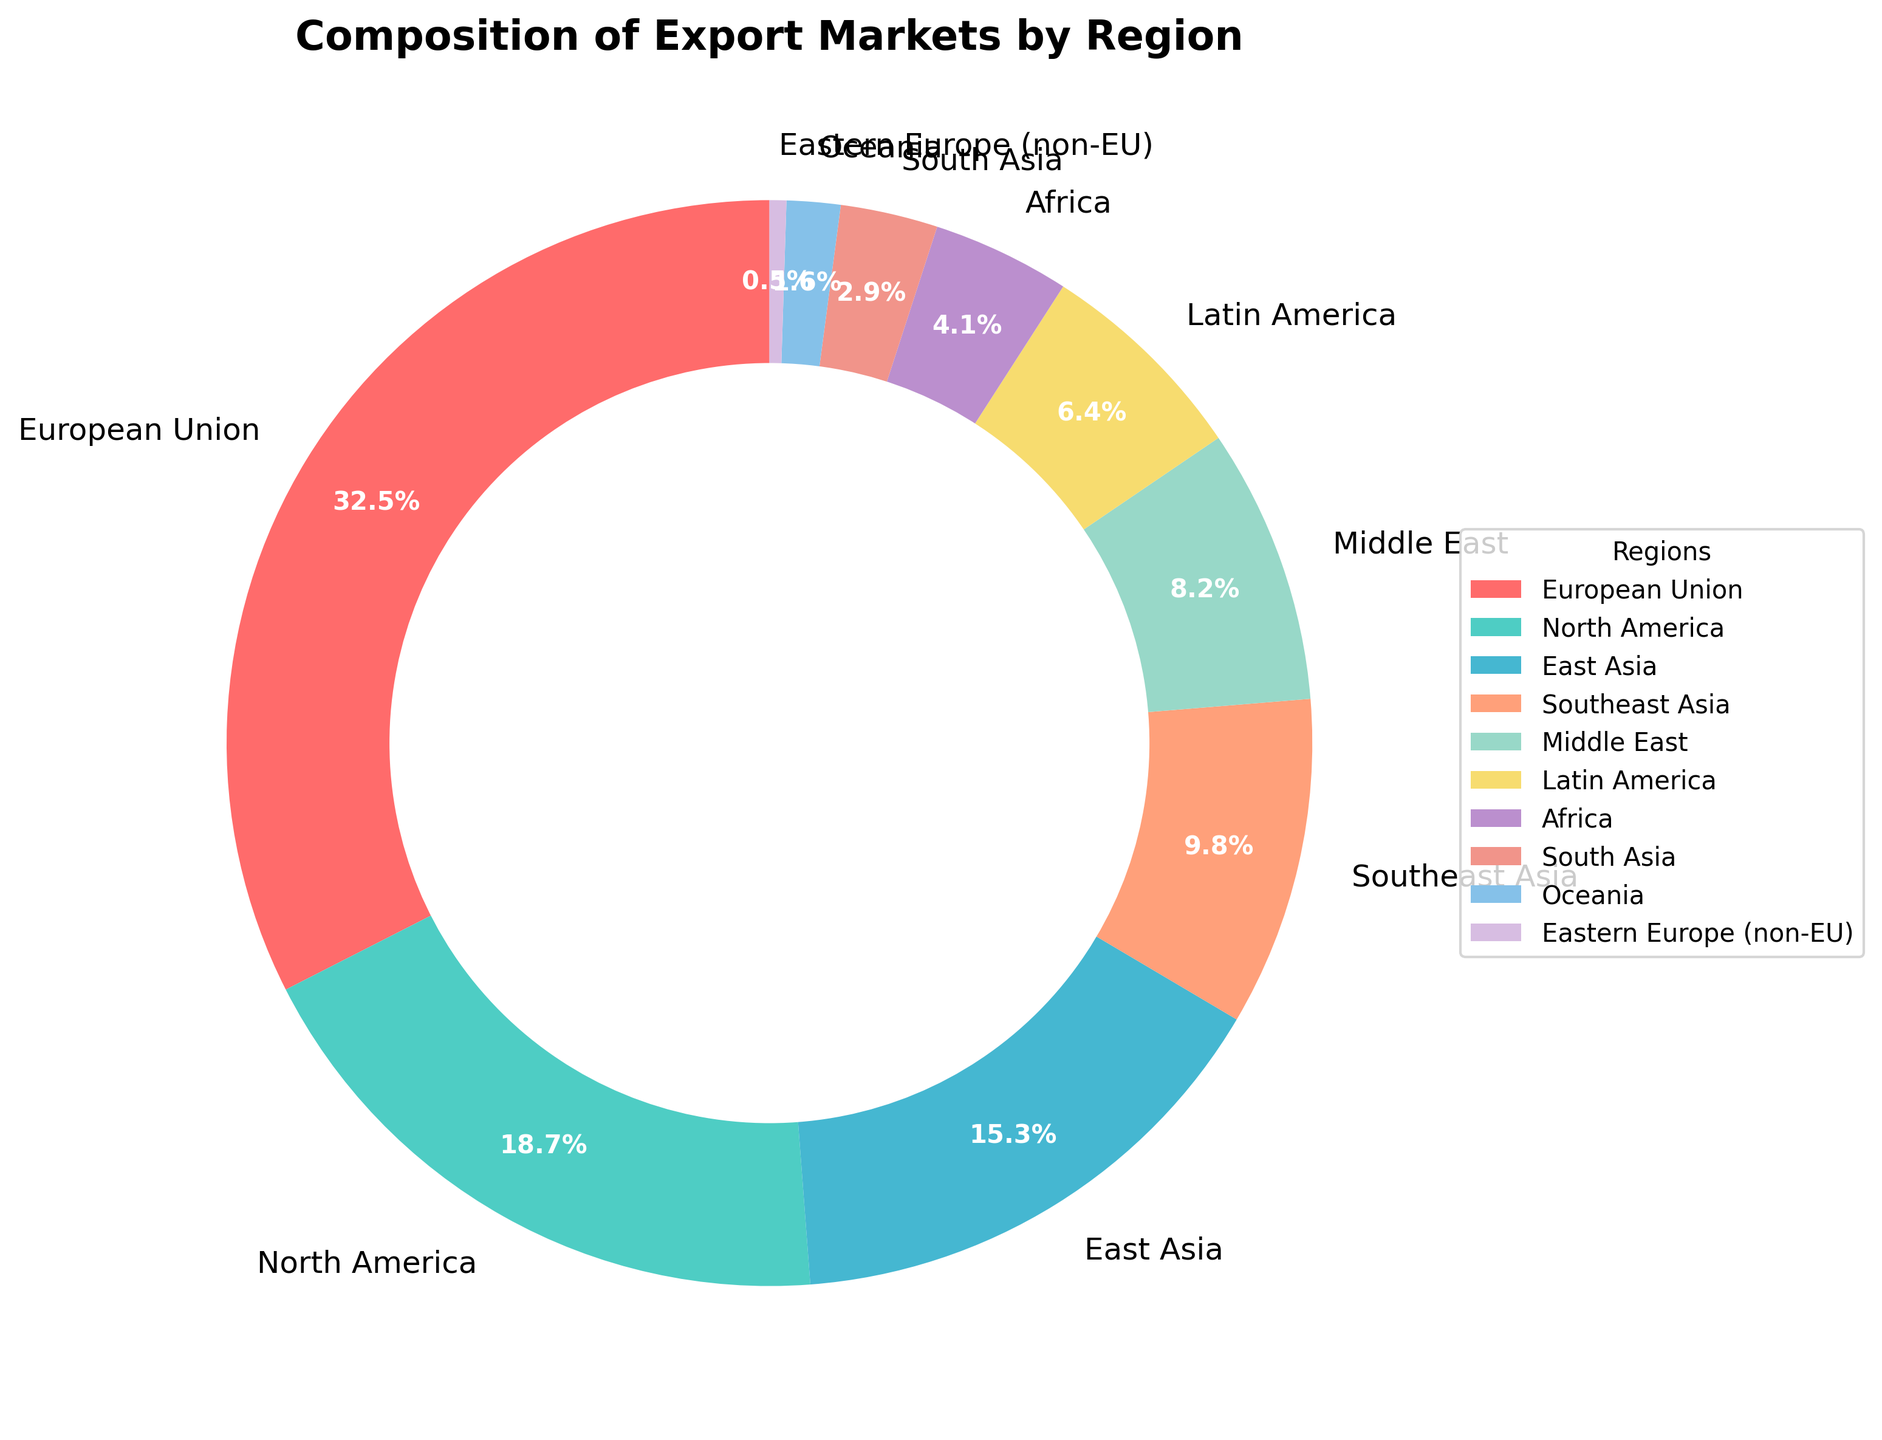What is the total percentage of exports to the Asian regions (East Asia, Southeast Asia, South Asia)? Add the percentages for East Asia (15.3%), Southeast Asia (9.8%), and South Asia (2.9%). The total is 15.3 + 9.8 + 2.9 = 28.0%.
Answer: 28.0% Which region has the highest percentage of exports? The region with the highest percentage is the one labeled with the largest percentage number. The European Union has the highest at 32.5%.
Answer: European Union What is the difference in export percentages between North America and Latin America? Subtract the percentage for Latin America from that of North America. The difference is 18.7 - 6.4 = 12.3%.
Answer: 12.3% What percentage of exports go to regions with less than 5% individual export shares? Add the percentages for Africa (4.1%), South Asia (2.9%), Oceania (1.6%), and Eastern Europe (non-EU) (0.5%). The total is 4.1 + 2.9 + 1.6 + 0.5 = 9.1%.
Answer: 9.1% Is the percentage of exports to the European Union greater than the combined percentage of Southeast Asia and the Middle East? Compare the percentage of exports to the European Union (32.5%) with the combined percentage of Southeast Asia (9.8%) and the Middle East (8.2%). Combined, they are 9.8 + 8.2 = 18.0%. 32.5% is greater than 18.0%.
Answer: Yes What is the dominant color of the segment representing North America in the pie chart? Look for the color of the segment labeled "North America" in the pie chart. The color is represented by one of the custom colors defined (second color in the list).
Answer: Turquoise Which regions together account for just over 50% of the exports? Sum the percentages starting from the highest until the total exceeds 50%. European Union (32.5%), North America (18.7%). Together they sum up to 32.5 + 18.7 = 51.2%.
Answer: European Union and North America Among Latin America, Africa, and Oceania, which region has the smallest export percentage? Compare the percentages of Latin America (6.4%), Africa (4.1%), and Oceania (1.6%). Oceania has the smallest percentage.
Answer: Oceania What is the combined percentage of exports to North America and East Asia, and is it greater than the percentage of exports to the European Union? Add the percentages of North America (18.7%) and East Asia (15.3%). Their combined percentage is 18.7 + 15.3 = 34.0%. Compare it with that of the European Union (32.5%). 34.0% is greater than 32.5%.
Answer: Yes, 34.0% How many regions have export percentages between 5% and 10%? Identify the regions with export percentages in this range. Southeast Asia (9.8%) and Latin America (6.4%) fall in this category, so there are 2 regions.
Answer: 2 regions 